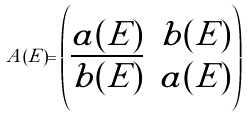Convert formula to latex. <formula><loc_0><loc_0><loc_500><loc_500>A ( E ) = \begin{pmatrix} a ( E ) & b ( E ) \\ \overline { b ( E ) } & a ( E ) \end{pmatrix}</formula> 